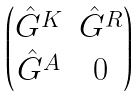<formula> <loc_0><loc_0><loc_500><loc_500>\begin{pmatrix} \hat { G } ^ { K } & \hat { G } ^ { R } \\ \hat { G } ^ { A } & 0 \end{pmatrix}</formula> 